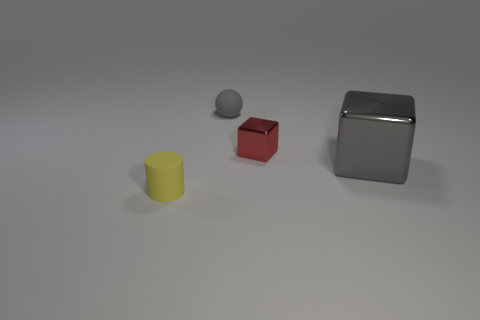Add 3 small shiny cylinders. How many objects exist? 7 Subtract all spheres. How many objects are left? 3 Add 2 blue metallic balls. How many blue metallic balls exist? 2 Subtract 0 green spheres. How many objects are left? 4 Subtract all gray metal blocks. Subtract all small purple rubber balls. How many objects are left? 3 Add 3 yellow things. How many yellow things are left? 4 